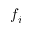<formula> <loc_0><loc_0><loc_500><loc_500>f _ { i }</formula> 